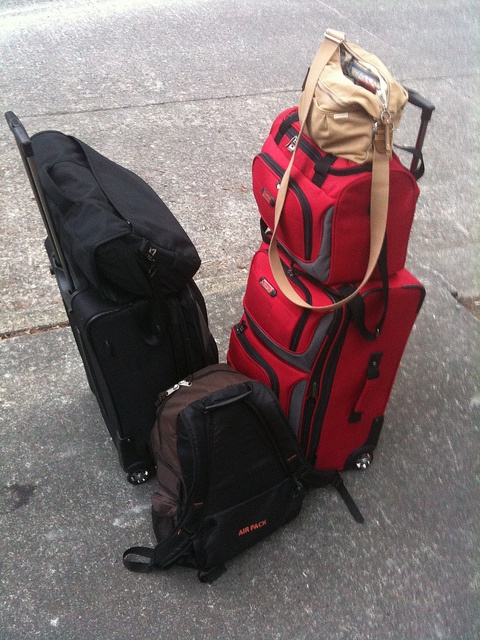Describe the objects in this image and their specific colors. I can see suitcase in lightgray, black, gray, and darkgray tones, suitcase in lightgray, maroon, black, brown, and gray tones, backpack in lightgray, black, gray, and brown tones, suitcase in lightgray, maroon, brown, and black tones, and handbag in lightgray and black tones in this image. 